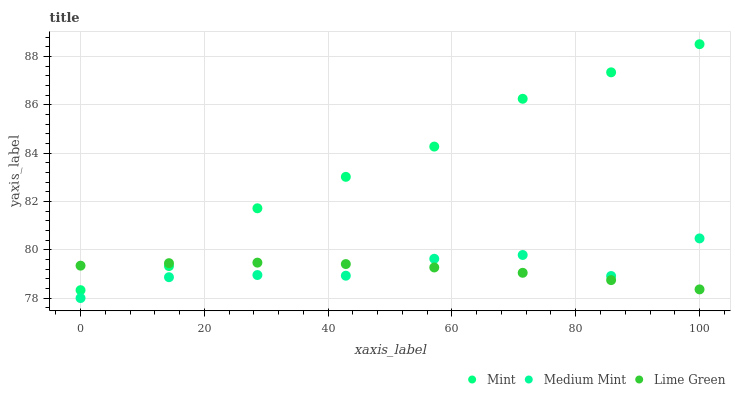Does Lime Green have the minimum area under the curve?
Answer yes or no. Yes. Does Mint have the maximum area under the curve?
Answer yes or no. Yes. Does Mint have the minimum area under the curve?
Answer yes or no. No. Does Lime Green have the maximum area under the curve?
Answer yes or no. No. Is Lime Green the smoothest?
Answer yes or no. Yes. Is Medium Mint the roughest?
Answer yes or no. Yes. Is Mint the smoothest?
Answer yes or no. No. Is Mint the roughest?
Answer yes or no. No. Does Medium Mint have the lowest value?
Answer yes or no. Yes. Does Mint have the lowest value?
Answer yes or no. No. Does Mint have the highest value?
Answer yes or no. Yes. Does Lime Green have the highest value?
Answer yes or no. No. Is Medium Mint less than Mint?
Answer yes or no. Yes. Is Mint greater than Medium Mint?
Answer yes or no. Yes. Does Lime Green intersect Mint?
Answer yes or no. Yes. Is Lime Green less than Mint?
Answer yes or no. No. Is Lime Green greater than Mint?
Answer yes or no. No. Does Medium Mint intersect Mint?
Answer yes or no. No. 